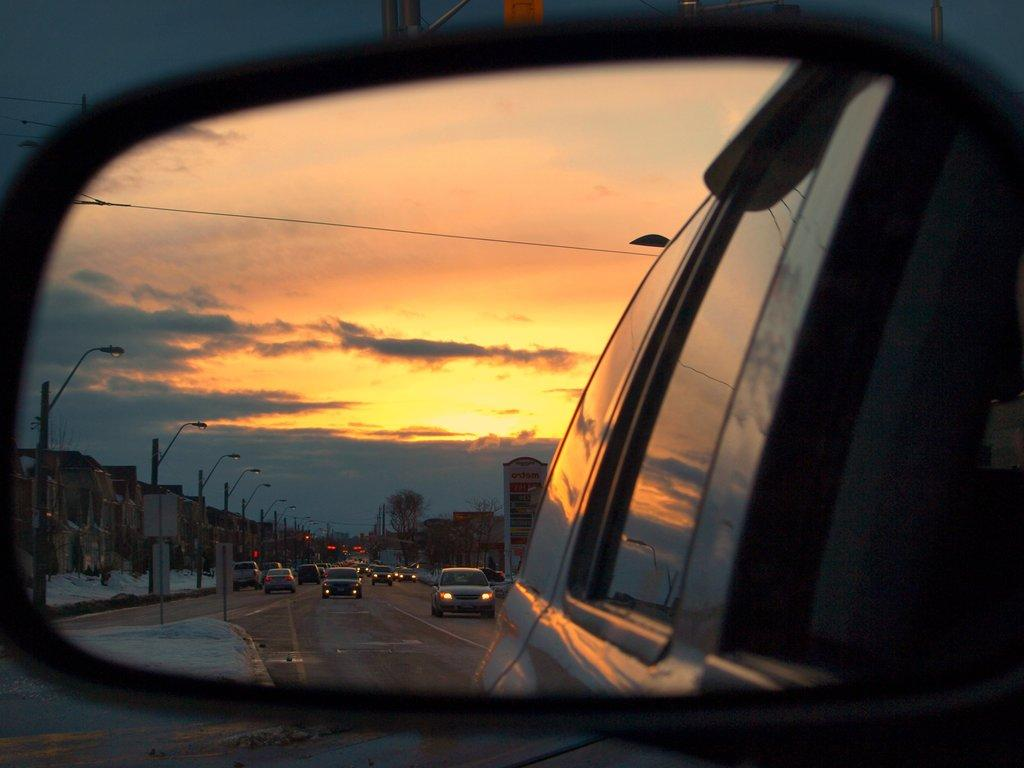What can be seen on the road in the image? There are vehicles on the road in the image. What is present in the background of the image? There are street lights, buildings, and the sky visible in the background of the image. What type of chalk is being used to draw on the dinosaurs in the image? There are no dinosaurs or chalk present in the image. What is being served for lunch in the image? The image does not depict any food or lunch-related items. 